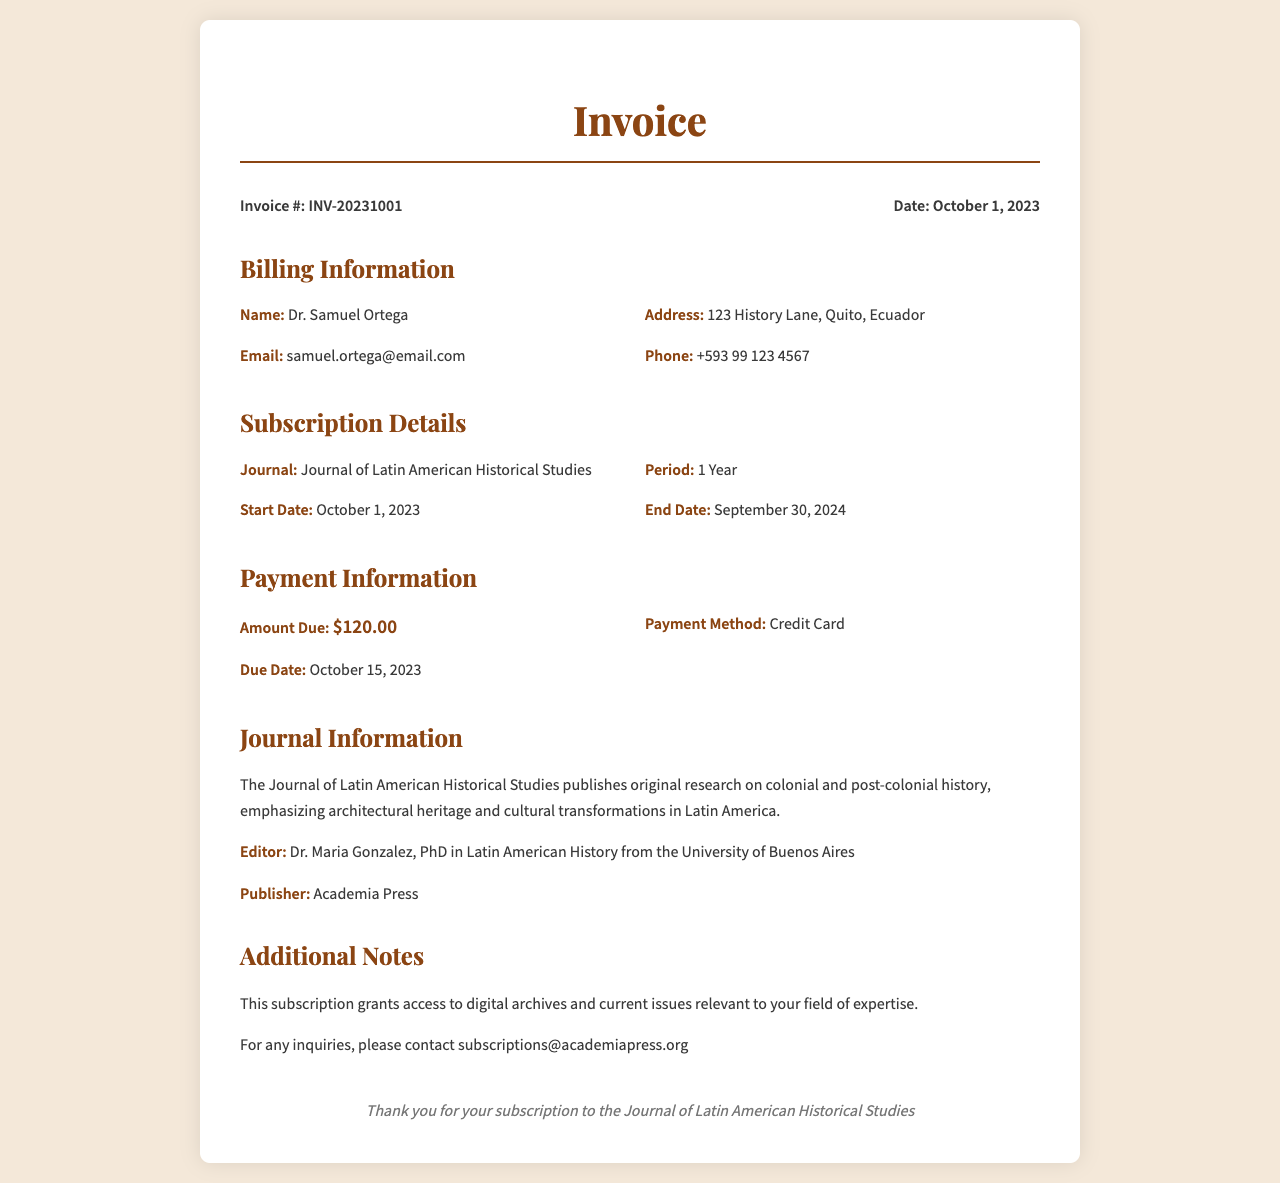What is the Invoice number? The Invoice number is directly mentioned in the document as "INV-20231001."
Answer: INV-20231001 What is the Amount Due? The Amount Due is specified under Payment Information in the document as "$120.00."
Answer: $120.00 What is the start date of the subscription? The start date of the subscription is presented as "October 1, 2023."
Answer: October 1, 2023 Who is the editor of the journal? The editor's name is provided in the Journal Information section as "Dr. Maria Gonzalez."
Answer: Dr. Maria Gonzalez What is the due date for payment? The due date for payment is specified in the document as "October 15, 2023."
Answer: October 15, 2023 What period does the subscription cover? The period of the subscription is mentioned as "1 Year."
Answer: 1 Year What does the subscription grant access to? The document states that the subscription provides access to "digital archives and current issues."
Answer: digital archives and current issues Which publisher is associated with the journal? The publisher's name is found in the Journal Information section as "Academia Press."
Answer: Academia Press What payment method was used? The document indicates the payment method in the Payment Information section as "Credit Card."
Answer: Credit Card 